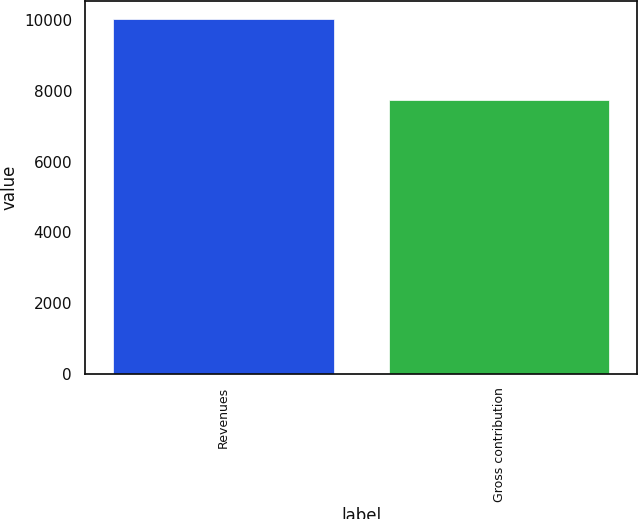Convert chart. <chart><loc_0><loc_0><loc_500><loc_500><bar_chart><fcel>Revenues<fcel>Gross contribution<nl><fcel>10045<fcel>7738<nl></chart> 